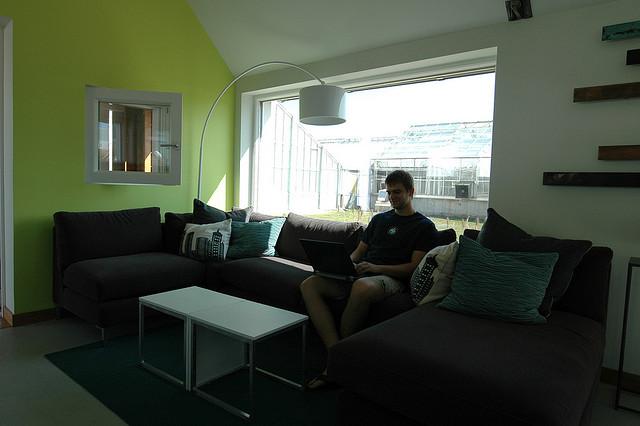What is the man doing on the sofa?
Keep it brief. Using laptop. What color is the left side wall?
Quick response, please. Green. What color is the table?
Quick response, please. White. Are there any people sitting on the couch?
Answer briefly. Yes. What is the man working on?
Give a very brief answer. Laptop. What is on the person's feet?
Quick response, please. Shoes. Is this room sparsely furnished?
Concise answer only. No. Is this playing with a phone?
Quick response, please. No. Where are the pillows?
Answer briefly. Couch. 